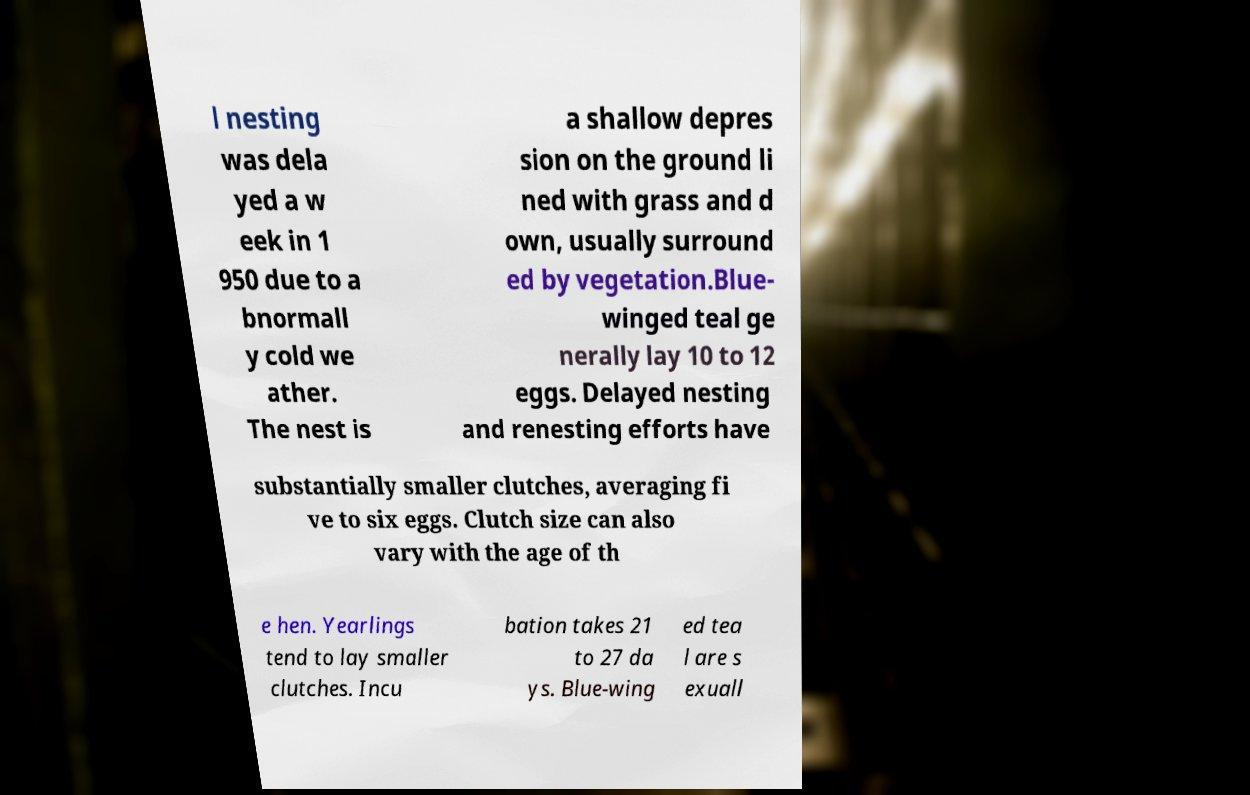Can you accurately transcribe the text from the provided image for me? l nesting was dela yed a w eek in 1 950 due to a bnormall y cold we ather. The nest is a shallow depres sion on the ground li ned with grass and d own, usually surround ed by vegetation.Blue- winged teal ge nerally lay 10 to 12 eggs. Delayed nesting and renesting efforts have substantially smaller clutches, averaging fi ve to six eggs. Clutch size can also vary with the age of th e hen. Yearlings tend to lay smaller clutches. Incu bation takes 21 to 27 da ys. Blue-wing ed tea l are s exuall 